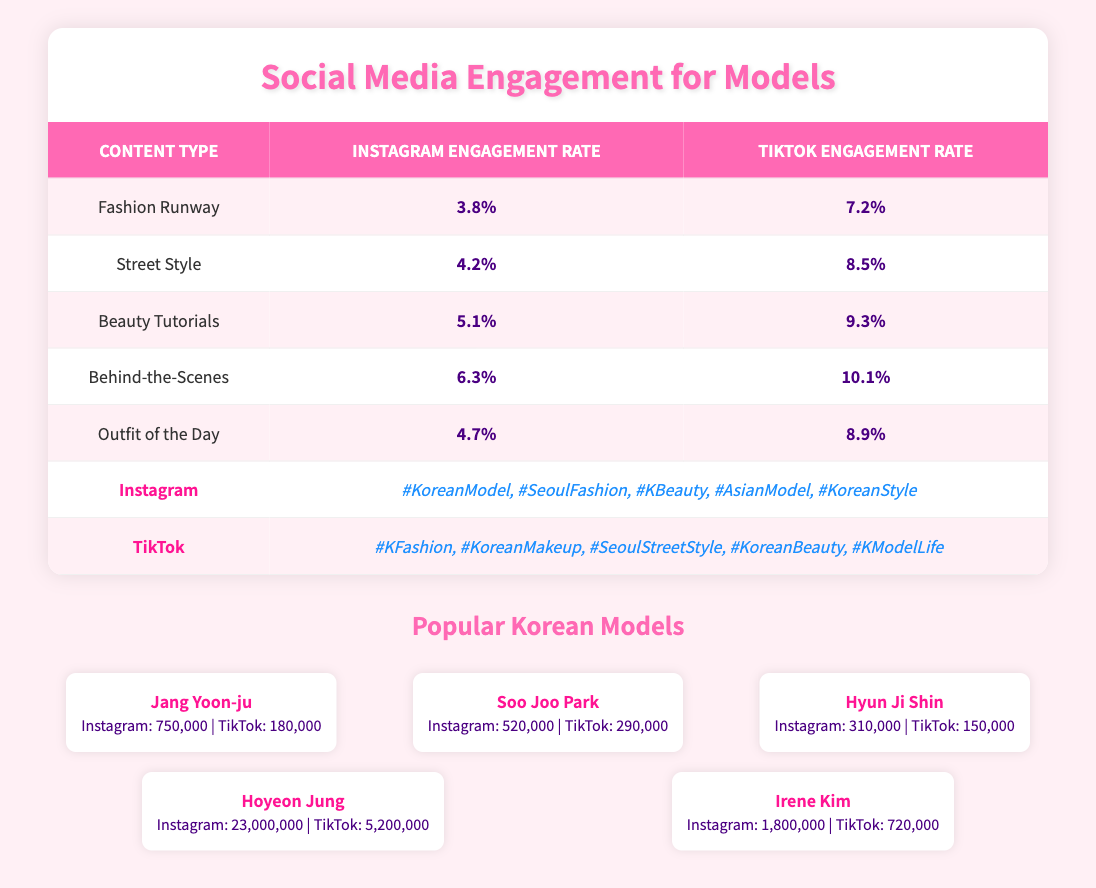What is the engagement rate for Beauty Tutorials on Instagram? According to the table, the engagement rate for Beauty Tutorials specifically under the Instagram category is listed as 5.1%.
Answer: 5.1% Which platform has a higher engagement rate for Behind-the-Scenes content? The table shows that the engagement rate for Behind-the-Scenes on Instagram is 6.3%, while on TikTok it is 10.1%. Therefore, TikTok has a higher engagement rate for this content type.
Answer: TikTok What is the average engagement rate for Street Style and Outfit of the Day on Instagram? To find the average, first sum the engagement rates for Street Style (4.2%) and Outfit of the Day (4.7%), which gives 4.2 + 4.7 = 8.9%, then divide by 2: 8.9% / 2 = 4.45%.
Answer: 4.45% Is the engagement rate for Fashion Runway higher on TikTok than on Instagram? The engagement rate for Fashion Runway on TikTok is 7.2%, while on Instagram it is 3.8%. Since 7.2% is greater than 3.8%, this statement is true.
Answer: Yes Which content type has the highest engagement rate on TikTok? Looking through the engagement rates for TikTok, the highest is for Beauty Tutorials at 9.3%.
Answer: Beauty Tutorials 